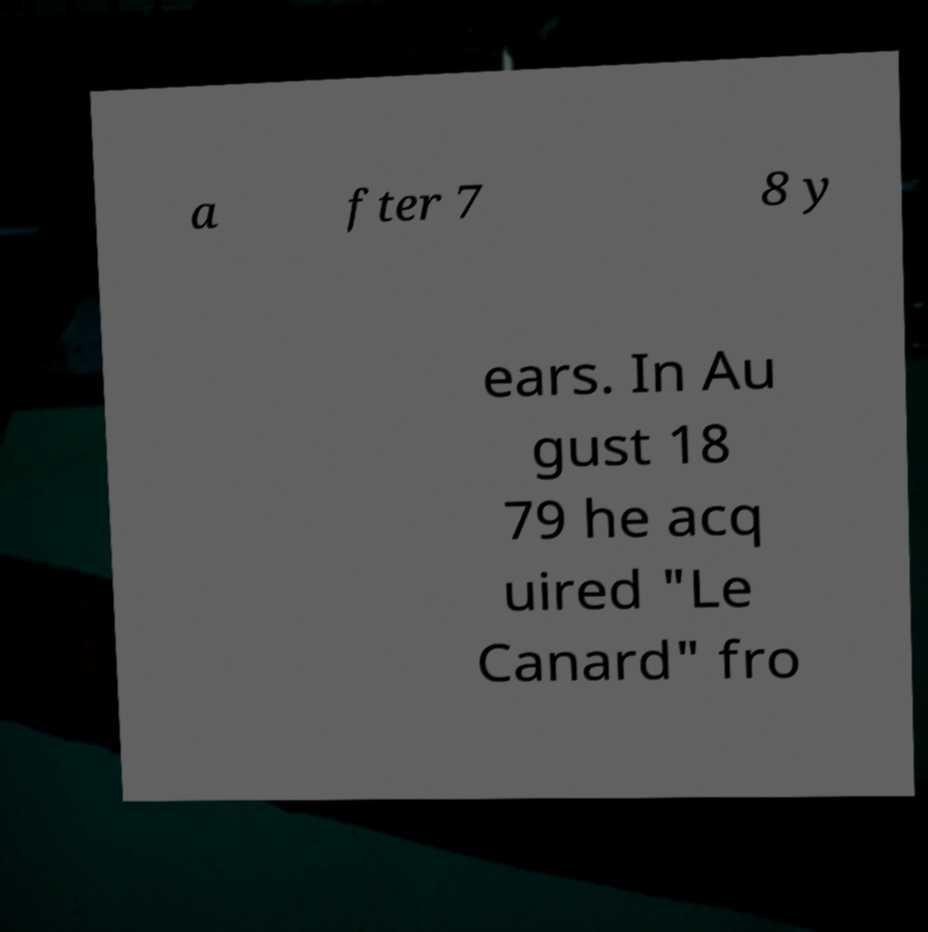Please read and relay the text visible in this image. What does it say? a fter 7 8 y ears. In Au gust 18 79 he acq uired "Le Canard" fro 